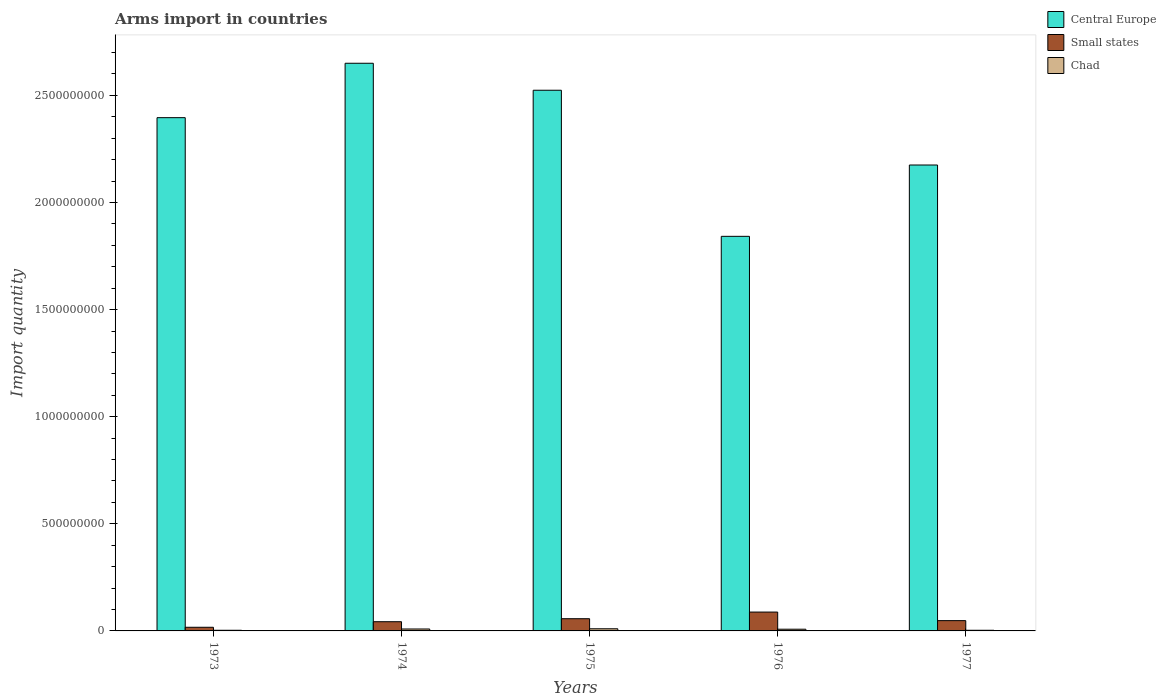How many groups of bars are there?
Ensure brevity in your answer.  5. Are the number of bars per tick equal to the number of legend labels?
Provide a short and direct response. Yes. Are the number of bars on each tick of the X-axis equal?
Make the answer very short. Yes. How many bars are there on the 5th tick from the left?
Make the answer very short. 3. What is the label of the 4th group of bars from the left?
Keep it short and to the point. 1976. In how many cases, is the number of bars for a given year not equal to the number of legend labels?
Keep it short and to the point. 0. Across all years, what is the maximum total arms import in Small states?
Ensure brevity in your answer.  8.80e+07. Across all years, what is the minimum total arms import in Chad?
Offer a terse response. 3.00e+06. In which year was the total arms import in Central Europe maximum?
Keep it short and to the point. 1974. What is the total total arms import in Small states in the graph?
Ensure brevity in your answer.  2.53e+08. What is the difference between the total arms import in Small states in 1975 and that in 1977?
Offer a terse response. 9.00e+06. What is the difference between the total arms import in Small states in 1973 and the total arms import in Chad in 1977?
Keep it short and to the point. 1.40e+07. What is the average total arms import in Central Europe per year?
Give a very brief answer. 2.32e+09. In the year 1977, what is the difference between the total arms import in Small states and total arms import in Chad?
Keep it short and to the point. 4.50e+07. In how many years, is the total arms import in Chad greater than 1600000000?
Offer a very short reply. 0. What is the ratio of the total arms import in Small states in 1973 to that in 1977?
Provide a succinct answer. 0.35. Is the total arms import in Central Europe in 1973 less than that in 1975?
Provide a short and direct response. Yes. What is the difference between the highest and the second highest total arms import in Small states?
Ensure brevity in your answer.  3.10e+07. What is the difference between the highest and the lowest total arms import in Central Europe?
Make the answer very short. 8.08e+08. Is the sum of the total arms import in Small states in 1975 and 1976 greater than the maximum total arms import in Central Europe across all years?
Offer a terse response. No. What does the 2nd bar from the left in 1976 represents?
Your response must be concise. Small states. What does the 3rd bar from the right in 1975 represents?
Ensure brevity in your answer.  Central Europe. Is it the case that in every year, the sum of the total arms import in Small states and total arms import in Chad is greater than the total arms import in Central Europe?
Give a very brief answer. No. Are all the bars in the graph horizontal?
Provide a succinct answer. No. How many years are there in the graph?
Keep it short and to the point. 5. What is the difference between two consecutive major ticks on the Y-axis?
Ensure brevity in your answer.  5.00e+08. Are the values on the major ticks of Y-axis written in scientific E-notation?
Your answer should be very brief. No. Where does the legend appear in the graph?
Your answer should be very brief. Top right. How many legend labels are there?
Offer a terse response. 3. How are the legend labels stacked?
Make the answer very short. Vertical. What is the title of the graph?
Offer a very short reply. Arms import in countries. What is the label or title of the X-axis?
Provide a succinct answer. Years. What is the label or title of the Y-axis?
Offer a very short reply. Import quantity. What is the Import quantity in Central Europe in 1973?
Make the answer very short. 2.40e+09. What is the Import quantity in Small states in 1973?
Ensure brevity in your answer.  1.70e+07. What is the Import quantity of Central Europe in 1974?
Ensure brevity in your answer.  2.65e+09. What is the Import quantity of Small states in 1974?
Ensure brevity in your answer.  4.30e+07. What is the Import quantity in Chad in 1974?
Offer a terse response. 9.00e+06. What is the Import quantity of Central Europe in 1975?
Keep it short and to the point. 2.52e+09. What is the Import quantity in Small states in 1975?
Offer a terse response. 5.70e+07. What is the Import quantity of Central Europe in 1976?
Ensure brevity in your answer.  1.84e+09. What is the Import quantity of Small states in 1976?
Make the answer very short. 8.80e+07. What is the Import quantity of Chad in 1976?
Provide a succinct answer. 8.00e+06. What is the Import quantity in Central Europe in 1977?
Keep it short and to the point. 2.18e+09. What is the Import quantity in Small states in 1977?
Give a very brief answer. 4.80e+07. Across all years, what is the maximum Import quantity in Central Europe?
Provide a succinct answer. 2.65e+09. Across all years, what is the maximum Import quantity in Small states?
Make the answer very short. 8.80e+07. Across all years, what is the minimum Import quantity in Central Europe?
Your answer should be compact. 1.84e+09. Across all years, what is the minimum Import quantity in Small states?
Ensure brevity in your answer.  1.70e+07. What is the total Import quantity of Central Europe in the graph?
Offer a terse response. 1.16e+1. What is the total Import quantity of Small states in the graph?
Offer a very short reply. 2.53e+08. What is the total Import quantity in Chad in the graph?
Make the answer very short. 3.30e+07. What is the difference between the Import quantity in Central Europe in 1973 and that in 1974?
Provide a succinct answer. -2.54e+08. What is the difference between the Import quantity in Small states in 1973 and that in 1974?
Keep it short and to the point. -2.60e+07. What is the difference between the Import quantity of Chad in 1973 and that in 1974?
Keep it short and to the point. -6.00e+06. What is the difference between the Import quantity of Central Europe in 1973 and that in 1975?
Make the answer very short. -1.28e+08. What is the difference between the Import quantity of Small states in 1973 and that in 1975?
Offer a terse response. -4.00e+07. What is the difference between the Import quantity of Chad in 1973 and that in 1975?
Offer a terse response. -7.00e+06. What is the difference between the Import quantity of Central Europe in 1973 and that in 1976?
Your answer should be compact. 5.54e+08. What is the difference between the Import quantity in Small states in 1973 and that in 1976?
Your answer should be compact. -7.10e+07. What is the difference between the Import quantity in Chad in 1973 and that in 1976?
Give a very brief answer. -5.00e+06. What is the difference between the Import quantity in Central Europe in 1973 and that in 1977?
Give a very brief answer. 2.21e+08. What is the difference between the Import quantity of Small states in 1973 and that in 1977?
Your answer should be very brief. -3.10e+07. What is the difference between the Import quantity in Central Europe in 1974 and that in 1975?
Offer a very short reply. 1.26e+08. What is the difference between the Import quantity in Small states in 1974 and that in 1975?
Offer a very short reply. -1.40e+07. What is the difference between the Import quantity in Central Europe in 1974 and that in 1976?
Your answer should be compact. 8.08e+08. What is the difference between the Import quantity in Small states in 1974 and that in 1976?
Provide a short and direct response. -4.50e+07. What is the difference between the Import quantity of Central Europe in 1974 and that in 1977?
Your answer should be compact. 4.75e+08. What is the difference between the Import quantity of Small states in 1974 and that in 1977?
Keep it short and to the point. -5.00e+06. What is the difference between the Import quantity of Central Europe in 1975 and that in 1976?
Your answer should be very brief. 6.82e+08. What is the difference between the Import quantity in Small states in 1975 and that in 1976?
Ensure brevity in your answer.  -3.10e+07. What is the difference between the Import quantity in Central Europe in 1975 and that in 1977?
Provide a succinct answer. 3.49e+08. What is the difference between the Import quantity in Small states in 1975 and that in 1977?
Offer a terse response. 9.00e+06. What is the difference between the Import quantity of Central Europe in 1976 and that in 1977?
Make the answer very short. -3.33e+08. What is the difference between the Import quantity in Small states in 1976 and that in 1977?
Offer a very short reply. 4.00e+07. What is the difference between the Import quantity in Chad in 1976 and that in 1977?
Provide a succinct answer. 5.00e+06. What is the difference between the Import quantity in Central Europe in 1973 and the Import quantity in Small states in 1974?
Make the answer very short. 2.35e+09. What is the difference between the Import quantity of Central Europe in 1973 and the Import quantity of Chad in 1974?
Ensure brevity in your answer.  2.39e+09. What is the difference between the Import quantity of Small states in 1973 and the Import quantity of Chad in 1974?
Your response must be concise. 8.00e+06. What is the difference between the Import quantity in Central Europe in 1973 and the Import quantity in Small states in 1975?
Make the answer very short. 2.34e+09. What is the difference between the Import quantity of Central Europe in 1973 and the Import quantity of Chad in 1975?
Your answer should be compact. 2.39e+09. What is the difference between the Import quantity in Central Europe in 1973 and the Import quantity in Small states in 1976?
Offer a terse response. 2.31e+09. What is the difference between the Import quantity in Central Europe in 1973 and the Import quantity in Chad in 1976?
Make the answer very short. 2.39e+09. What is the difference between the Import quantity in Small states in 1973 and the Import quantity in Chad in 1976?
Keep it short and to the point. 9.00e+06. What is the difference between the Import quantity of Central Europe in 1973 and the Import quantity of Small states in 1977?
Your response must be concise. 2.35e+09. What is the difference between the Import quantity in Central Europe in 1973 and the Import quantity in Chad in 1977?
Your answer should be very brief. 2.39e+09. What is the difference between the Import quantity in Small states in 1973 and the Import quantity in Chad in 1977?
Your answer should be compact. 1.40e+07. What is the difference between the Import quantity in Central Europe in 1974 and the Import quantity in Small states in 1975?
Provide a short and direct response. 2.59e+09. What is the difference between the Import quantity in Central Europe in 1974 and the Import quantity in Chad in 1975?
Provide a succinct answer. 2.64e+09. What is the difference between the Import quantity of Small states in 1974 and the Import quantity of Chad in 1975?
Offer a terse response. 3.30e+07. What is the difference between the Import quantity in Central Europe in 1974 and the Import quantity in Small states in 1976?
Your answer should be very brief. 2.56e+09. What is the difference between the Import quantity of Central Europe in 1974 and the Import quantity of Chad in 1976?
Offer a very short reply. 2.64e+09. What is the difference between the Import quantity in Small states in 1974 and the Import quantity in Chad in 1976?
Ensure brevity in your answer.  3.50e+07. What is the difference between the Import quantity of Central Europe in 1974 and the Import quantity of Small states in 1977?
Ensure brevity in your answer.  2.60e+09. What is the difference between the Import quantity in Central Europe in 1974 and the Import quantity in Chad in 1977?
Provide a succinct answer. 2.65e+09. What is the difference between the Import quantity in Small states in 1974 and the Import quantity in Chad in 1977?
Your answer should be compact. 4.00e+07. What is the difference between the Import quantity of Central Europe in 1975 and the Import quantity of Small states in 1976?
Offer a terse response. 2.44e+09. What is the difference between the Import quantity of Central Europe in 1975 and the Import quantity of Chad in 1976?
Keep it short and to the point. 2.52e+09. What is the difference between the Import quantity in Small states in 1975 and the Import quantity in Chad in 1976?
Your answer should be compact. 4.90e+07. What is the difference between the Import quantity of Central Europe in 1975 and the Import quantity of Small states in 1977?
Provide a short and direct response. 2.48e+09. What is the difference between the Import quantity in Central Europe in 1975 and the Import quantity in Chad in 1977?
Your answer should be very brief. 2.52e+09. What is the difference between the Import quantity of Small states in 1975 and the Import quantity of Chad in 1977?
Offer a very short reply. 5.40e+07. What is the difference between the Import quantity in Central Europe in 1976 and the Import quantity in Small states in 1977?
Ensure brevity in your answer.  1.79e+09. What is the difference between the Import quantity of Central Europe in 1976 and the Import quantity of Chad in 1977?
Your answer should be compact. 1.84e+09. What is the difference between the Import quantity of Small states in 1976 and the Import quantity of Chad in 1977?
Keep it short and to the point. 8.50e+07. What is the average Import quantity in Central Europe per year?
Your answer should be very brief. 2.32e+09. What is the average Import quantity of Small states per year?
Make the answer very short. 5.06e+07. What is the average Import quantity of Chad per year?
Your response must be concise. 6.60e+06. In the year 1973, what is the difference between the Import quantity of Central Europe and Import quantity of Small states?
Make the answer very short. 2.38e+09. In the year 1973, what is the difference between the Import quantity in Central Europe and Import quantity in Chad?
Provide a succinct answer. 2.39e+09. In the year 1973, what is the difference between the Import quantity of Small states and Import quantity of Chad?
Provide a succinct answer. 1.40e+07. In the year 1974, what is the difference between the Import quantity in Central Europe and Import quantity in Small states?
Your answer should be very brief. 2.61e+09. In the year 1974, what is the difference between the Import quantity in Central Europe and Import quantity in Chad?
Provide a short and direct response. 2.64e+09. In the year 1974, what is the difference between the Import quantity of Small states and Import quantity of Chad?
Offer a very short reply. 3.40e+07. In the year 1975, what is the difference between the Import quantity of Central Europe and Import quantity of Small states?
Make the answer very short. 2.47e+09. In the year 1975, what is the difference between the Import quantity of Central Europe and Import quantity of Chad?
Offer a very short reply. 2.51e+09. In the year 1975, what is the difference between the Import quantity of Small states and Import quantity of Chad?
Offer a very short reply. 4.70e+07. In the year 1976, what is the difference between the Import quantity in Central Europe and Import quantity in Small states?
Keep it short and to the point. 1.75e+09. In the year 1976, what is the difference between the Import quantity in Central Europe and Import quantity in Chad?
Provide a short and direct response. 1.83e+09. In the year 1976, what is the difference between the Import quantity of Small states and Import quantity of Chad?
Your answer should be very brief. 8.00e+07. In the year 1977, what is the difference between the Import quantity in Central Europe and Import quantity in Small states?
Provide a short and direct response. 2.13e+09. In the year 1977, what is the difference between the Import quantity of Central Europe and Import quantity of Chad?
Give a very brief answer. 2.17e+09. In the year 1977, what is the difference between the Import quantity in Small states and Import quantity in Chad?
Offer a terse response. 4.50e+07. What is the ratio of the Import quantity in Central Europe in 1973 to that in 1974?
Give a very brief answer. 0.9. What is the ratio of the Import quantity in Small states in 1973 to that in 1974?
Keep it short and to the point. 0.4. What is the ratio of the Import quantity in Chad in 1973 to that in 1974?
Offer a terse response. 0.33. What is the ratio of the Import quantity of Central Europe in 1973 to that in 1975?
Your response must be concise. 0.95. What is the ratio of the Import quantity in Small states in 1973 to that in 1975?
Provide a succinct answer. 0.3. What is the ratio of the Import quantity in Chad in 1973 to that in 1975?
Keep it short and to the point. 0.3. What is the ratio of the Import quantity of Central Europe in 1973 to that in 1976?
Your answer should be compact. 1.3. What is the ratio of the Import quantity of Small states in 1973 to that in 1976?
Your answer should be very brief. 0.19. What is the ratio of the Import quantity in Chad in 1973 to that in 1976?
Keep it short and to the point. 0.38. What is the ratio of the Import quantity of Central Europe in 1973 to that in 1977?
Ensure brevity in your answer.  1.1. What is the ratio of the Import quantity of Small states in 1973 to that in 1977?
Ensure brevity in your answer.  0.35. What is the ratio of the Import quantity of Chad in 1973 to that in 1977?
Give a very brief answer. 1. What is the ratio of the Import quantity of Central Europe in 1974 to that in 1975?
Keep it short and to the point. 1.05. What is the ratio of the Import quantity of Small states in 1974 to that in 1975?
Give a very brief answer. 0.75. What is the ratio of the Import quantity of Chad in 1974 to that in 1975?
Provide a succinct answer. 0.9. What is the ratio of the Import quantity of Central Europe in 1974 to that in 1976?
Make the answer very short. 1.44. What is the ratio of the Import quantity in Small states in 1974 to that in 1976?
Your response must be concise. 0.49. What is the ratio of the Import quantity of Chad in 1974 to that in 1976?
Your response must be concise. 1.12. What is the ratio of the Import quantity of Central Europe in 1974 to that in 1977?
Provide a succinct answer. 1.22. What is the ratio of the Import quantity of Small states in 1974 to that in 1977?
Ensure brevity in your answer.  0.9. What is the ratio of the Import quantity of Chad in 1974 to that in 1977?
Provide a succinct answer. 3. What is the ratio of the Import quantity in Central Europe in 1975 to that in 1976?
Keep it short and to the point. 1.37. What is the ratio of the Import quantity in Small states in 1975 to that in 1976?
Provide a succinct answer. 0.65. What is the ratio of the Import quantity in Chad in 1975 to that in 1976?
Make the answer very short. 1.25. What is the ratio of the Import quantity in Central Europe in 1975 to that in 1977?
Provide a short and direct response. 1.16. What is the ratio of the Import quantity of Small states in 1975 to that in 1977?
Offer a terse response. 1.19. What is the ratio of the Import quantity of Chad in 1975 to that in 1977?
Provide a succinct answer. 3.33. What is the ratio of the Import quantity of Central Europe in 1976 to that in 1977?
Ensure brevity in your answer.  0.85. What is the ratio of the Import quantity in Small states in 1976 to that in 1977?
Provide a succinct answer. 1.83. What is the ratio of the Import quantity in Chad in 1976 to that in 1977?
Ensure brevity in your answer.  2.67. What is the difference between the highest and the second highest Import quantity in Central Europe?
Give a very brief answer. 1.26e+08. What is the difference between the highest and the second highest Import quantity in Small states?
Keep it short and to the point. 3.10e+07. What is the difference between the highest and the second highest Import quantity in Chad?
Your answer should be compact. 1.00e+06. What is the difference between the highest and the lowest Import quantity of Central Europe?
Make the answer very short. 8.08e+08. What is the difference between the highest and the lowest Import quantity in Small states?
Your answer should be compact. 7.10e+07. 